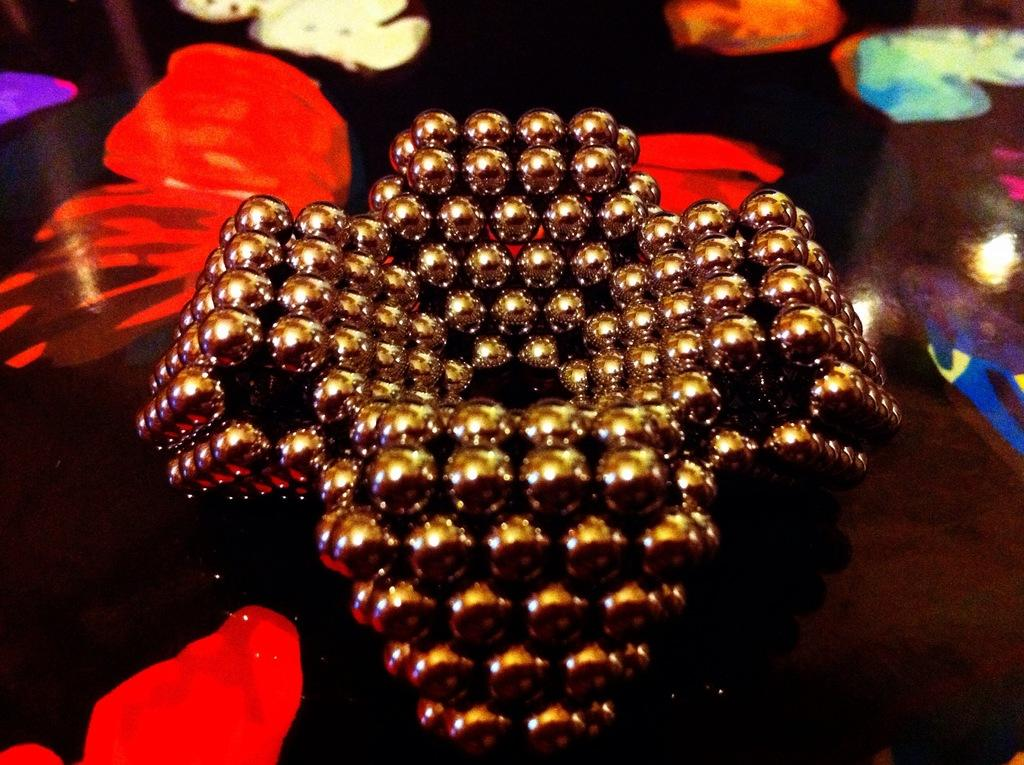What can be seen in the image that serves a decorative purpose? There is a decorative item in the image. Can you describe the location of the decorative item? The decorative item is on an object. How much credit does the farmer need to buy rice in the image? There is no farmer, credit, or rice mentioned in the image; it only features a decorative item on an object. 